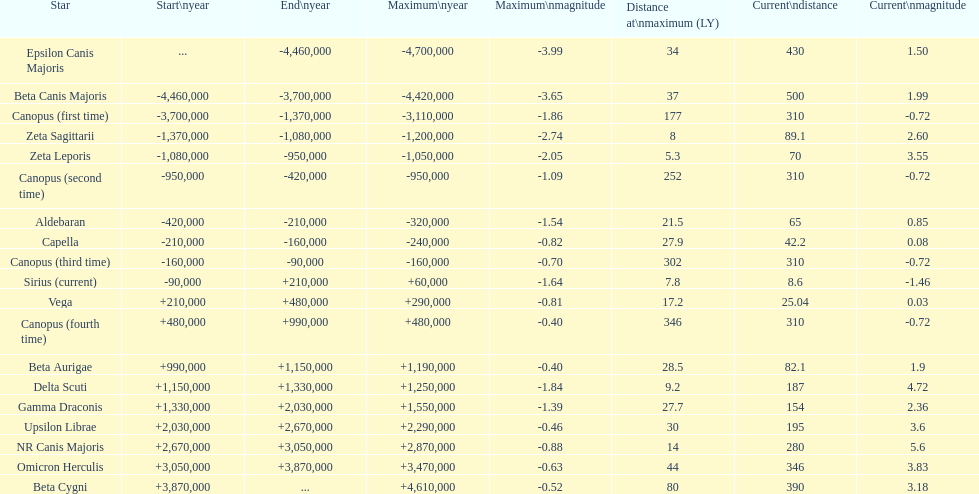By how many light years is epsilon canis majoris further than zeta sagittarii? 26. 